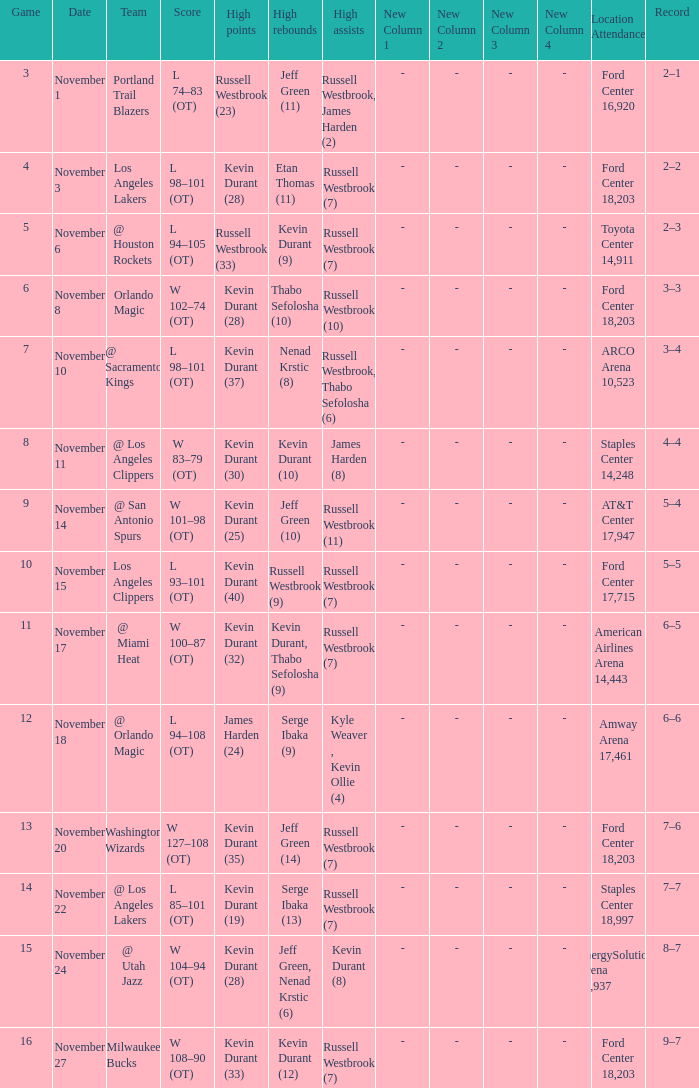When was the game number 3 played? November 1. 